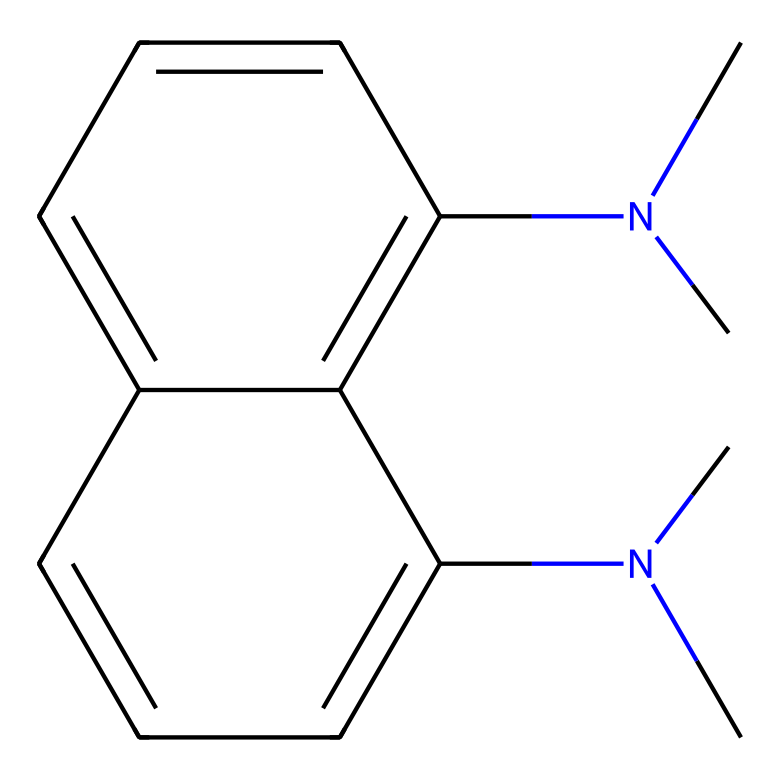what is the molecular formula of 1,8-bis(dimethylamino)naphthalene? By analyzing the structure based on the provided SMILES representation, we identify that there are 13 carbon atoms, 16 hydrogen atoms, and 2 nitrogen atoms, which when combined yield the molecular formula C13H16N2.
Answer: C13H16N2 how many nitrogen atoms are present in the structure? The SMILES representation contains "N(C)C" two times, indicating two nitrogen atoms in total in the molecular structure.
Answer: 2 what type of functional groups are present in this molecule? The primary functional groups present are the dimethylamino groups, indicated by "N(C)C," which suggest the presence of amine groups in the structure.
Answer: amine groups which component of the structure contributes to its basicity? The dimethylamino groups are basic due to the presence of lone pairs on nitrogen, which can accept protons, thus contributing to the high basicity of this superbase.
Answer: dimethylamino groups what structural feature indicates that this compound is a superbase? The presence of multiple electron-donating dimethylamino groups significantly increases the electron density, enhancing proton-accepting ability, which is characteristic of superbases.
Answer: electron-donating groups how many fused benzene rings are present in the naphthalene structure? The naphthalene core consists of two fused benzene rings, which can be recognized from the continuous c1cccc2cccc structure in the SMILES.
Answer: 2 